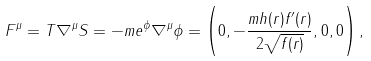<formula> <loc_0><loc_0><loc_500><loc_500>F ^ { \mu } = T \nabla ^ { \mu } S = - m e ^ { \phi } \nabla ^ { \mu } \phi = \left ( 0 , - \frac { m h ( r ) f ^ { \prime } ( r ) } { 2 \sqrt { f ( r ) } } , 0 , 0 \right ) ,</formula> 